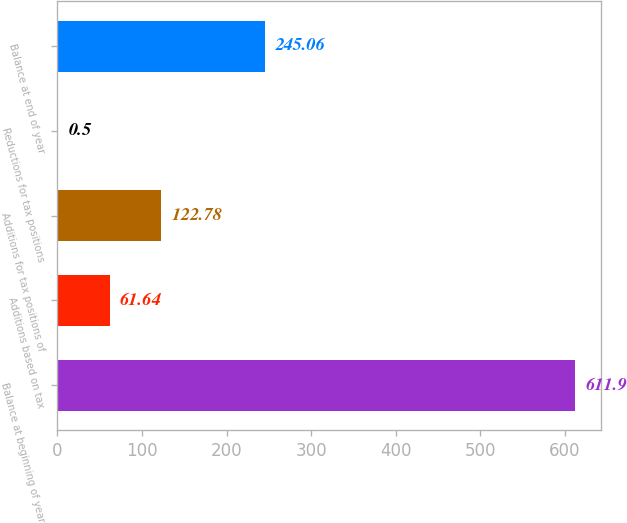Convert chart. <chart><loc_0><loc_0><loc_500><loc_500><bar_chart><fcel>Balance at beginning of year<fcel>Additions based on tax<fcel>Additions for tax positions of<fcel>Reductions for tax positions<fcel>Balance at end of year<nl><fcel>611.9<fcel>61.64<fcel>122.78<fcel>0.5<fcel>245.06<nl></chart> 